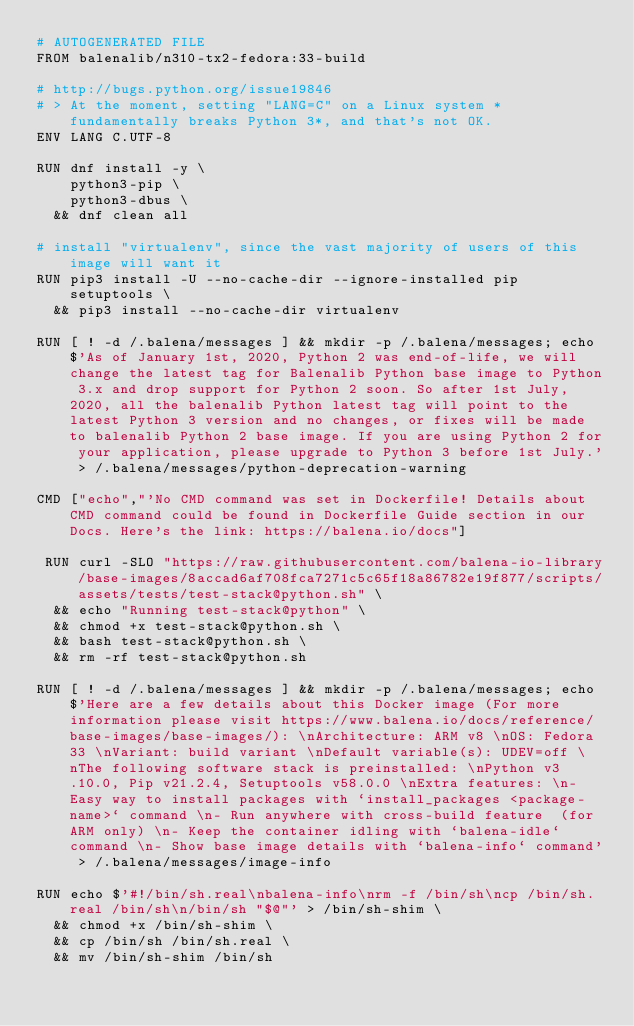Convert code to text. <code><loc_0><loc_0><loc_500><loc_500><_Dockerfile_># AUTOGENERATED FILE
FROM balenalib/n310-tx2-fedora:33-build

# http://bugs.python.org/issue19846
# > At the moment, setting "LANG=C" on a Linux system *fundamentally breaks Python 3*, and that's not OK.
ENV LANG C.UTF-8

RUN dnf install -y \
		python3-pip \
		python3-dbus \
	&& dnf clean all

# install "virtualenv", since the vast majority of users of this image will want it
RUN pip3 install -U --no-cache-dir --ignore-installed pip setuptools \
	&& pip3 install --no-cache-dir virtualenv

RUN [ ! -d /.balena/messages ] && mkdir -p /.balena/messages; echo $'As of January 1st, 2020, Python 2 was end-of-life, we will change the latest tag for Balenalib Python base image to Python 3.x and drop support for Python 2 soon. So after 1st July, 2020, all the balenalib Python latest tag will point to the latest Python 3 version and no changes, or fixes will be made to balenalib Python 2 base image. If you are using Python 2 for your application, please upgrade to Python 3 before 1st July.' > /.balena/messages/python-deprecation-warning

CMD ["echo","'No CMD command was set in Dockerfile! Details about CMD command could be found in Dockerfile Guide section in our Docs. Here's the link: https://balena.io/docs"]

 RUN curl -SLO "https://raw.githubusercontent.com/balena-io-library/base-images/8accad6af708fca7271c5c65f18a86782e19f877/scripts/assets/tests/test-stack@python.sh" \
  && echo "Running test-stack@python" \
  && chmod +x test-stack@python.sh \
  && bash test-stack@python.sh \
  && rm -rf test-stack@python.sh 

RUN [ ! -d /.balena/messages ] && mkdir -p /.balena/messages; echo $'Here are a few details about this Docker image (For more information please visit https://www.balena.io/docs/reference/base-images/base-images/): \nArchitecture: ARM v8 \nOS: Fedora 33 \nVariant: build variant \nDefault variable(s): UDEV=off \nThe following software stack is preinstalled: \nPython v3.10.0, Pip v21.2.4, Setuptools v58.0.0 \nExtra features: \n- Easy way to install packages with `install_packages <package-name>` command \n- Run anywhere with cross-build feature  (for ARM only) \n- Keep the container idling with `balena-idle` command \n- Show base image details with `balena-info` command' > /.balena/messages/image-info

RUN echo $'#!/bin/sh.real\nbalena-info\nrm -f /bin/sh\ncp /bin/sh.real /bin/sh\n/bin/sh "$@"' > /bin/sh-shim \
	&& chmod +x /bin/sh-shim \
	&& cp /bin/sh /bin/sh.real \
	&& mv /bin/sh-shim /bin/sh</code> 